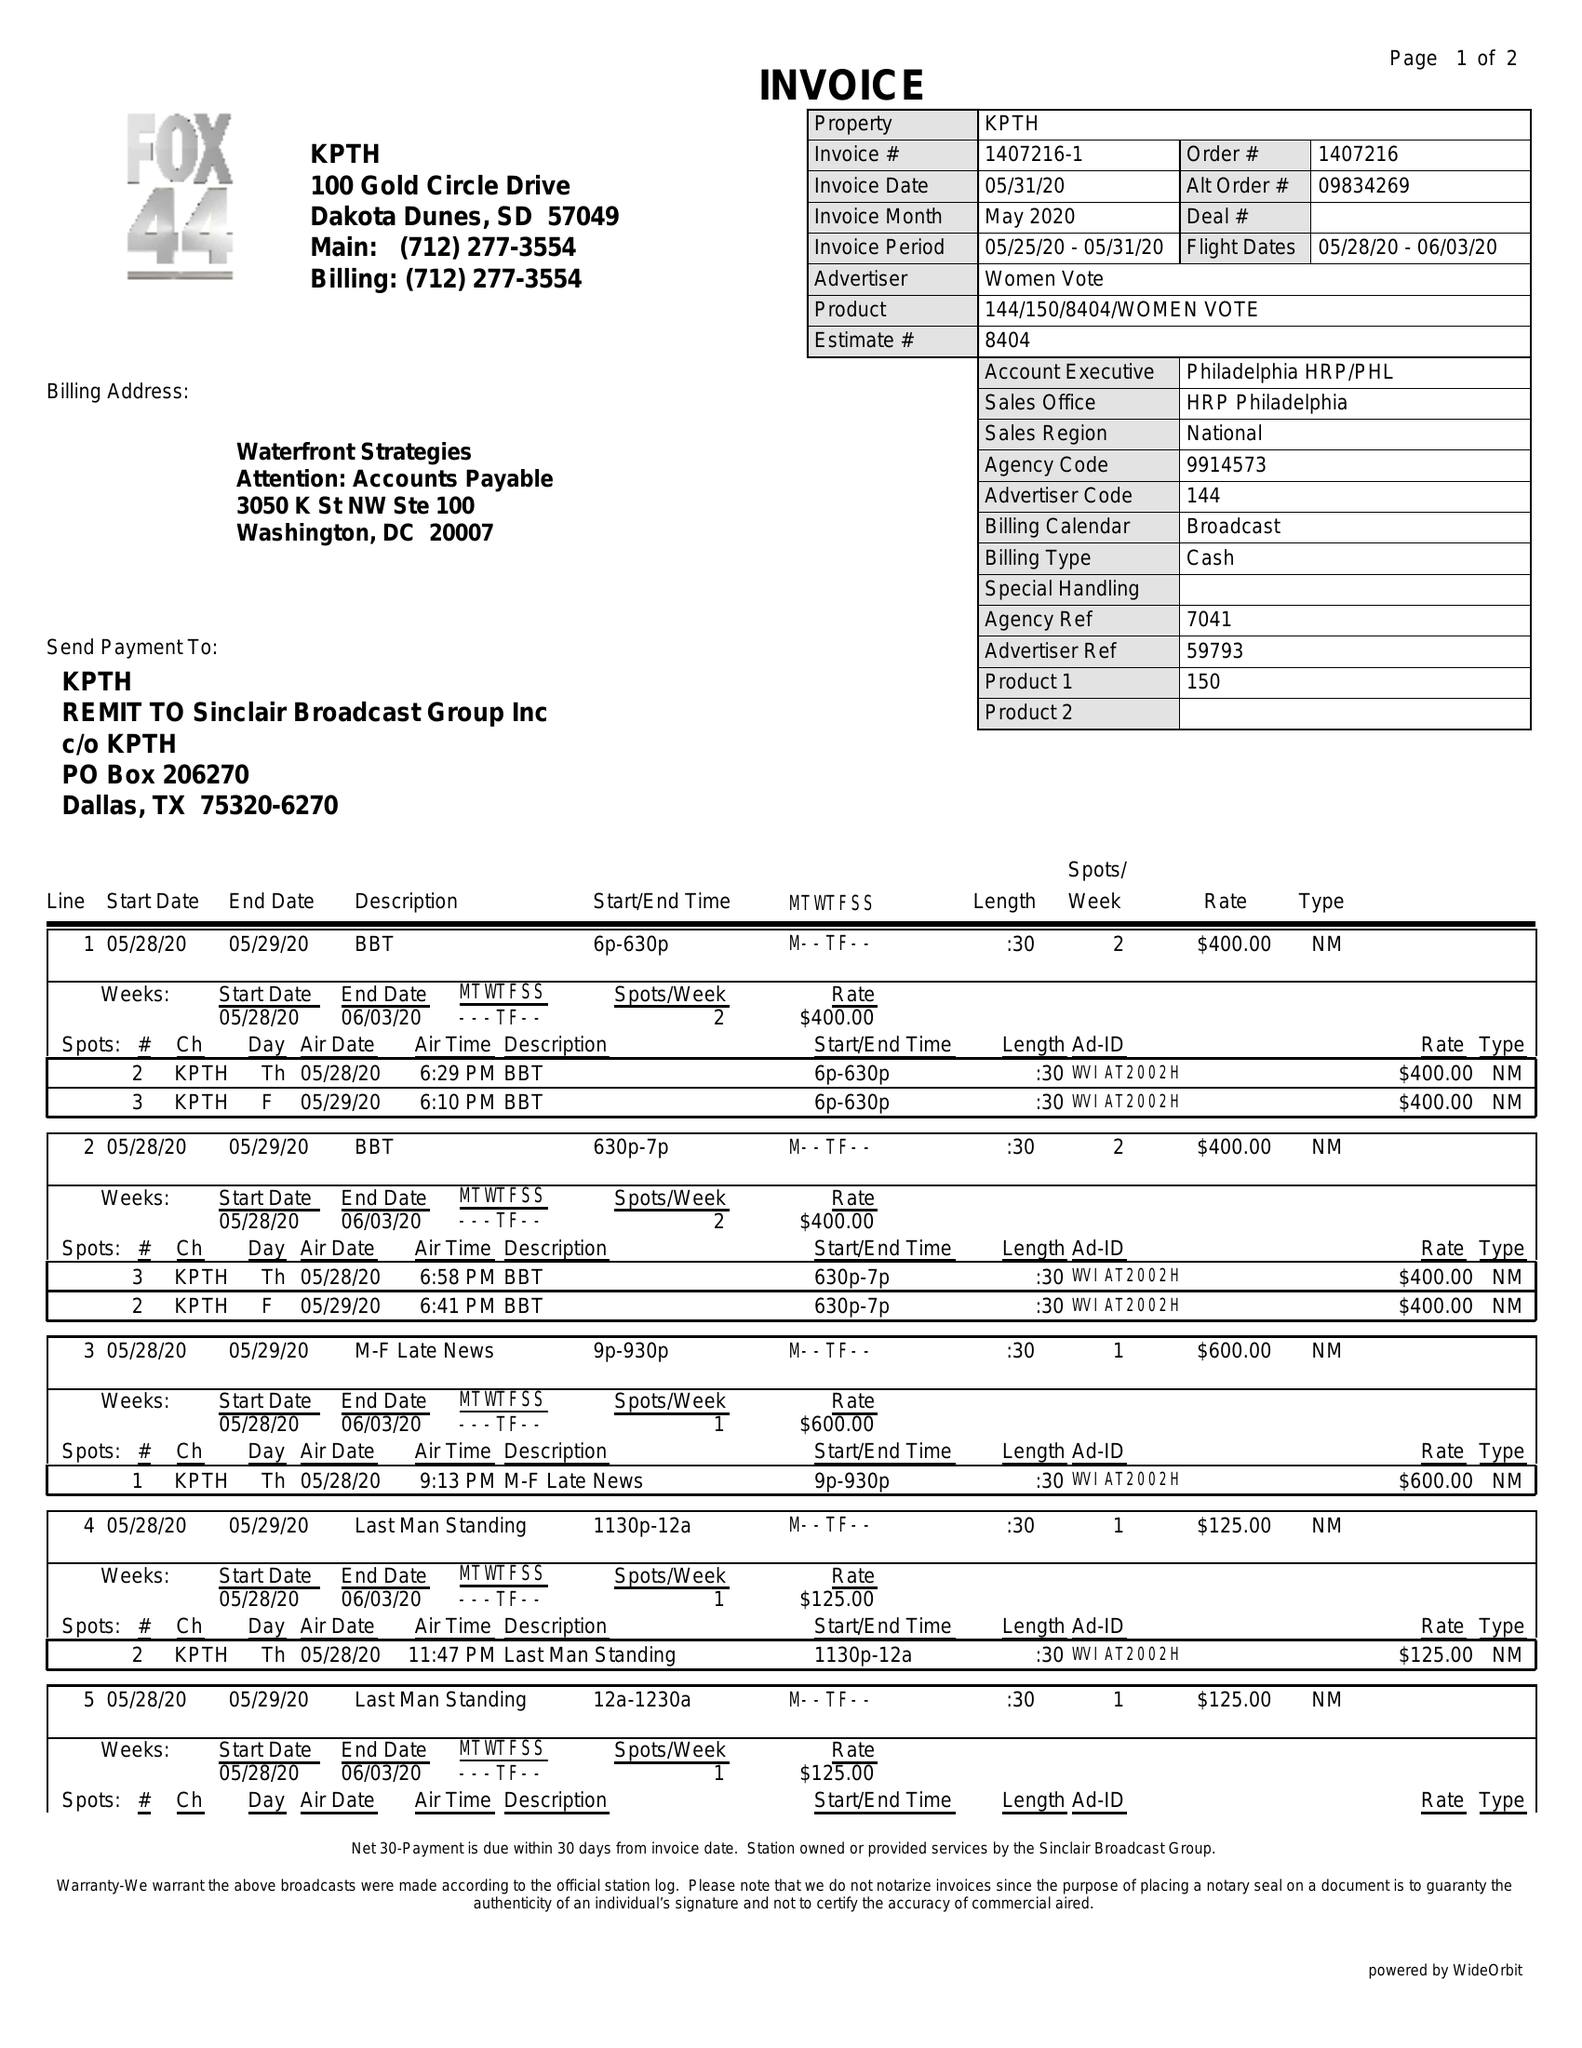What is the value for the contract_num?
Answer the question using a single word or phrase. 1407216 